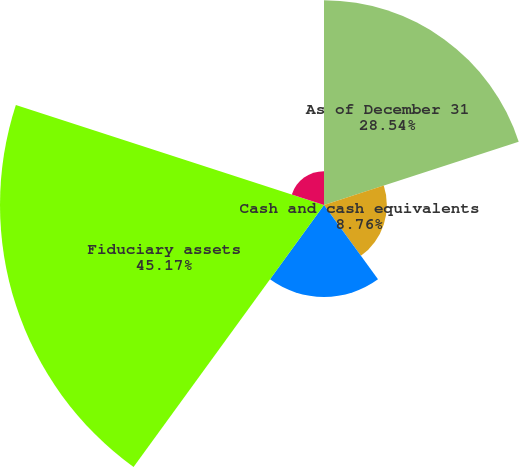Convert chart to OTSL. <chart><loc_0><loc_0><loc_500><loc_500><pie_chart><fcel>As of December 31<fcel>Cash and cash equivalents<fcel>Short-term investments<fcel>Fiduciary assets<fcel>Investments<nl><fcel>28.54%<fcel>8.76%<fcel>12.81%<fcel>45.17%<fcel>4.72%<nl></chart> 